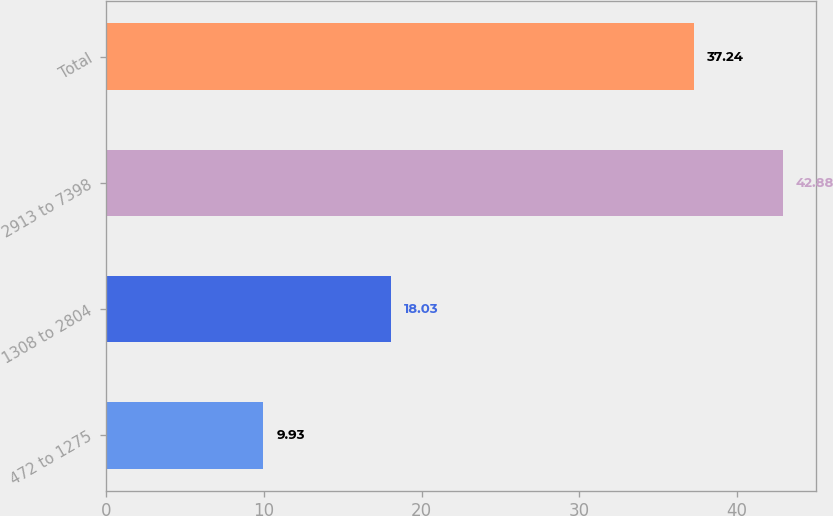<chart> <loc_0><loc_0><loc_500><loc_500><bar_chart><fcel>472 to 1275<fcel>1308 to 2804<fcel>2913 to 7398<fcel>Total<nl><fcel>9.93<fcel>18.03<fcel>42.88<fcel>37.24<nl></chart> 